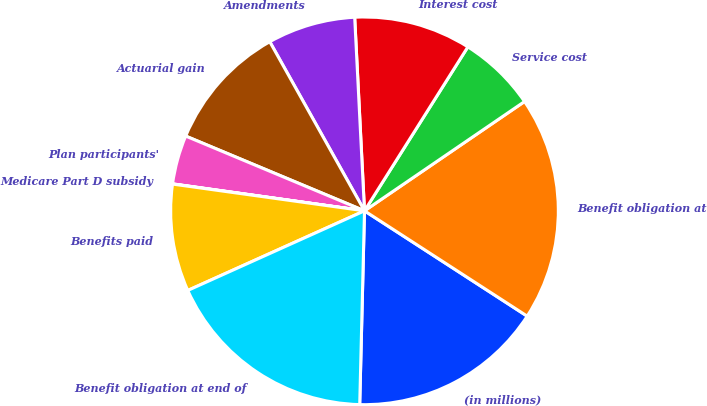Convert chart. <chart><loc_0><loc_0><loc_500><loc_500><pie_chart><fcel>(in millions)<fcel>Benefit obligation at<fcel>Service cost<fcel>Interest cost<fcel>Amendments<fcel>Actuarial gain<fcel>Plan participants'<fcel>Medicare Part D subsidy<fcel>Benefits paid<fcel>Benefit obligation at end of<nl><fcel>16.25%<fcel>18.68%<fcel>6.51%<fcel>9.76%<fcel>7.32%<fcel>10.57%<fcel>4.08%<fcel>0.02%<fcel>8.94%<fcel>17.87%<nl></chart> 